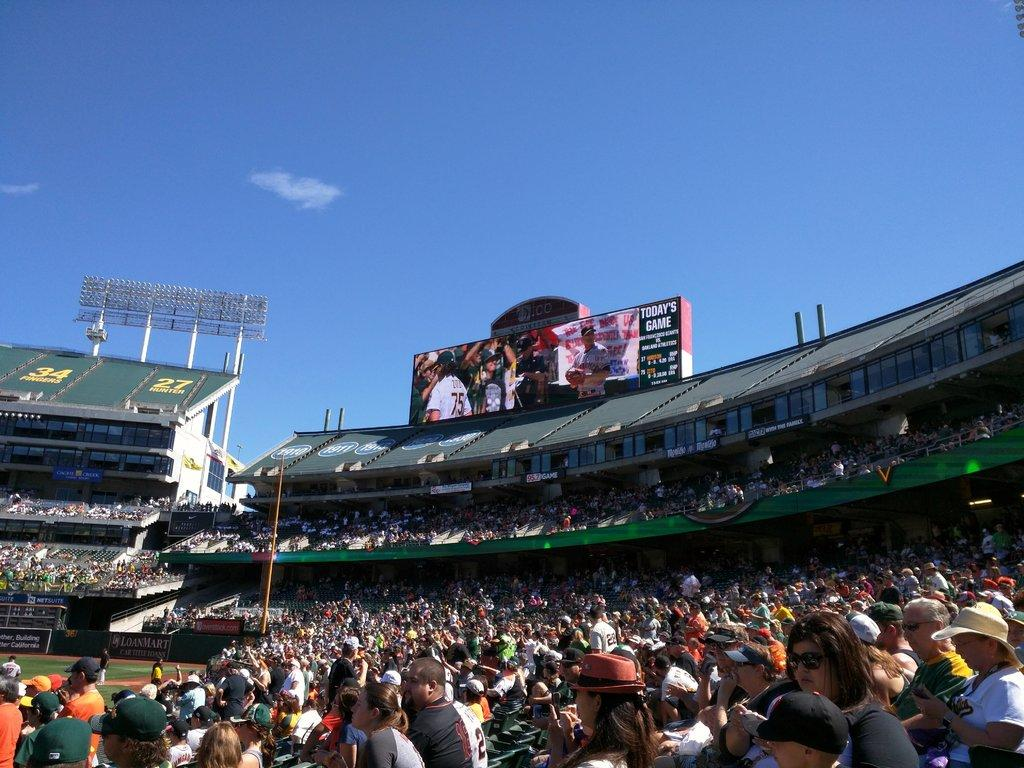How many people can be seen in the image? There are people in the image, but the exact number is not specified. What is the ground made of in the image? The ground is visible in the image, but the material it is made of is not mentioned. What type of vegetation is present in the image? There is grass in the image. What type of structure is in the image? There is a stadium in the image. What are the poles used for in the image? Poles are present in the image, but their purpose is not specified. What is written on the board in the image? There is a board in the image, but the content is not mentioned. What is the purpose of the floodlights in the image? Floodlights are visible in the image, and they are likely used for illuminating the area. What type of advertisements are present in the image? Hoardings are present in the image, which are used for advertising. What can be seen in the background of the image? The sky is visible in the background of the image. How many jellyfish are swimming in the image? There are no jellyfish present in the image. What is the value of the quarter in the image? There is no mention of a quarter in the image. 